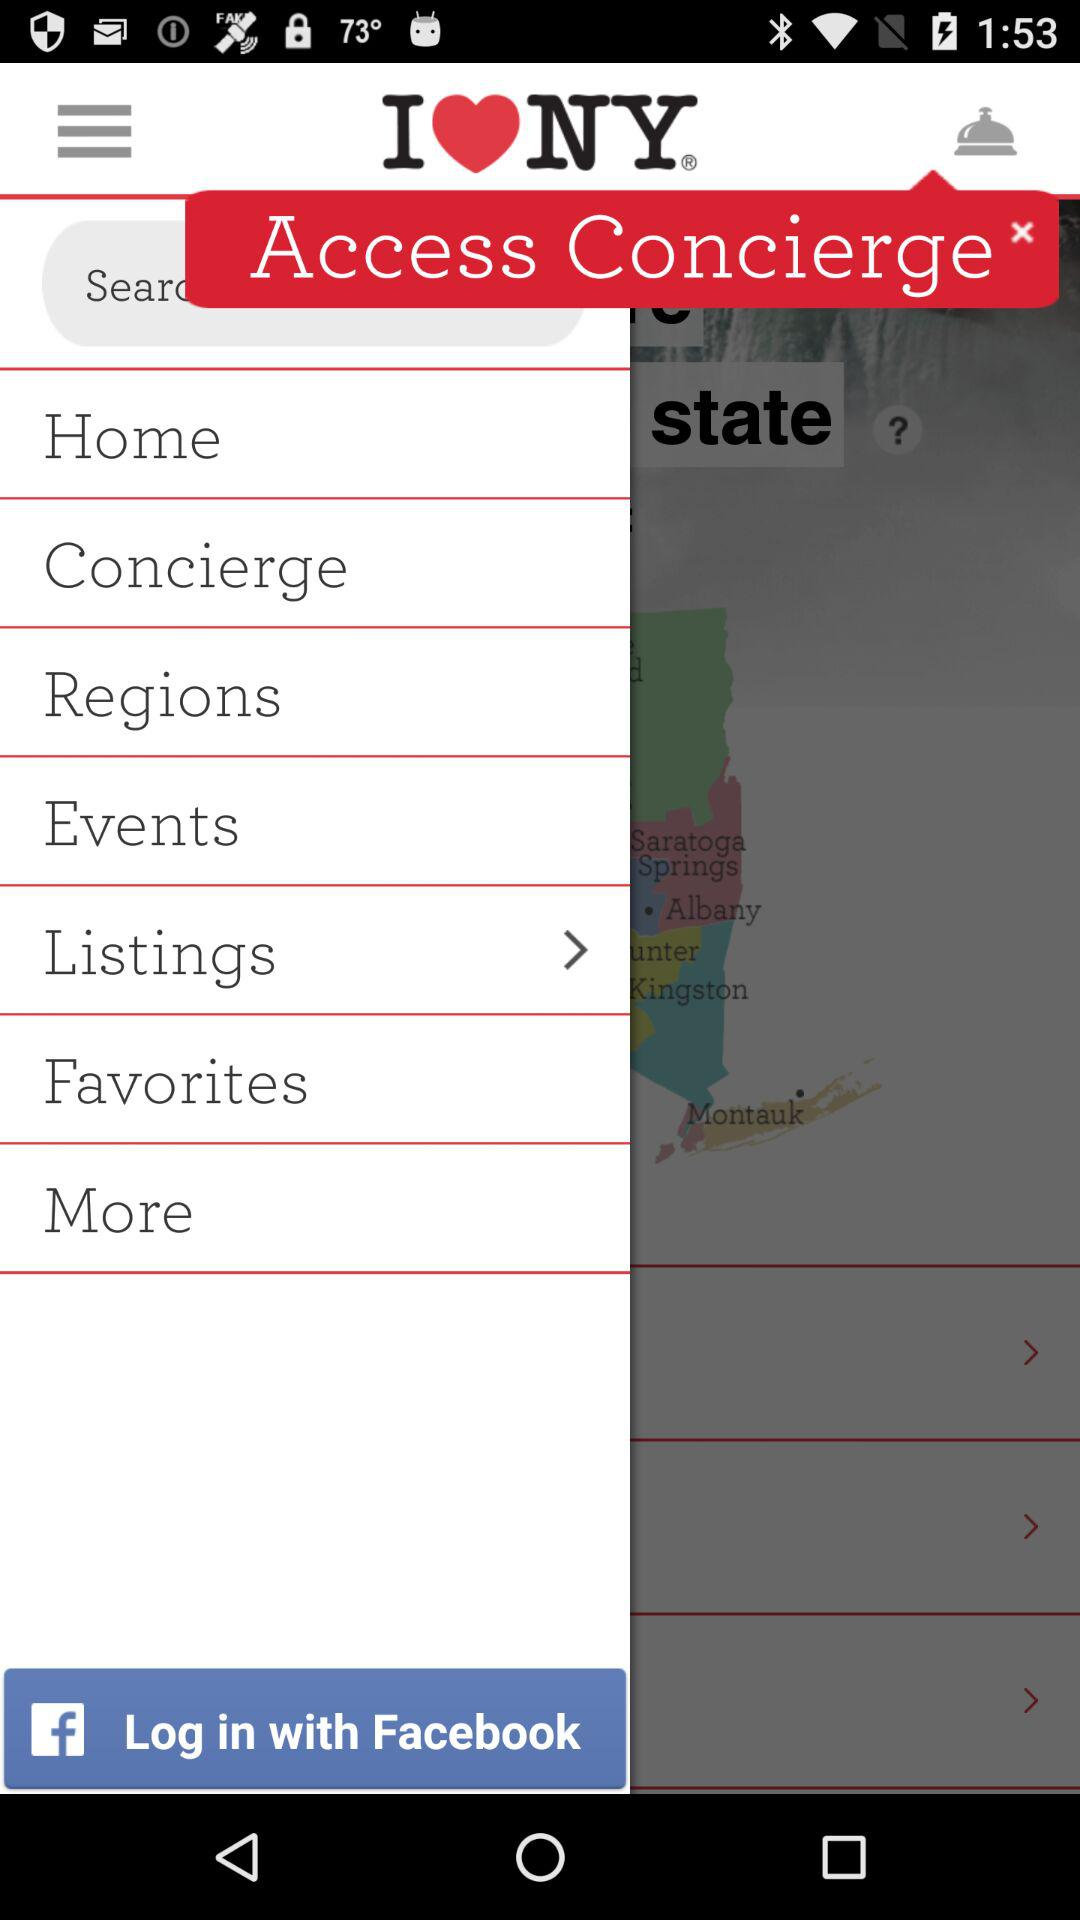What is the application through which we can log in? You can log in through "Facebook". 